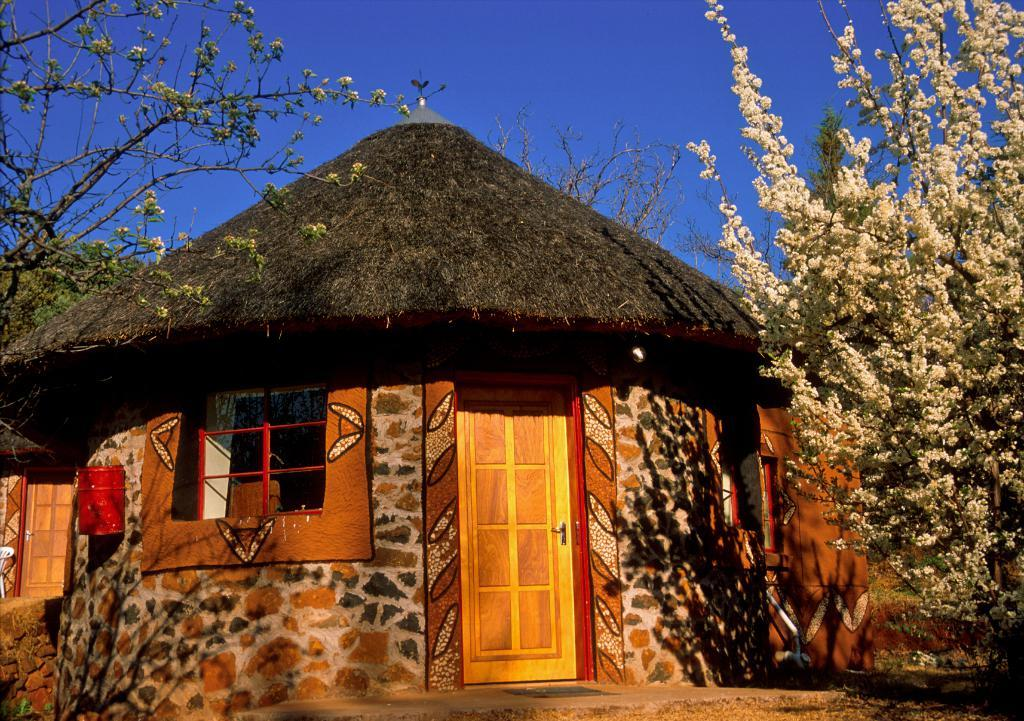What type of structure is visible in the image? There is a hut in the image. What can be seen on the left side of the image? There are trees on the left side of the image. What is present on the right side of the image? There are trees on the right side of the image. How would you describe the weather in the image? The sky is clear in the image, suggesting good weather. What type of protest is happening in front of the hut in the image? There is no protest visible in the image; it only shows a hut with trees on both sides and a clear sky. 